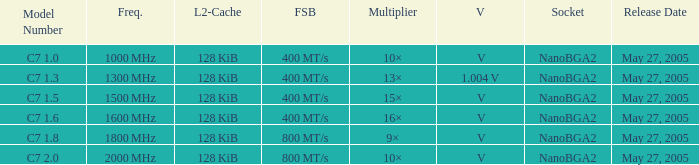What is the Frequency for Model Number c7 1.0? 1000 MHz. Parse the table in full. {'header': ['Model Number', 'Freq.', 'L2-Cache', 'FSB', 'Multiplier', 'V', 'Socket', 'Release Date'], 'rows': [['C7 1.0', '1000\u2009MHz', '128\u2009KiB', '400\u2009MT/s', '10×', '\u2009V', 'NanoBGA2', 'May 27, 2005'], ['C7 1.3', '1300\u2009MHz', '128\u2009KiB', '400\u2009MT/s', '13×', '1.004\u2009V', 'NanoBGA2', 'May 27, 2005'], ['C7 1.5', '1500\u2009MHz', '128\u2009KiB', '400\u2009MT/s', '15×', '\u2009V', 'NanoBGA2', 'May 27, 2005'], ['C7 1.6', '1600\u2009MHz', '128\u2009KiB', '400\u2009MT/s', '16×', '\u2009V', 'NanoBGA2', 'May 27, 2005'], ['C7 1.8', '1800\u2009MHz', '128\u2009KiB', '800\u2009MT/s', '9×', '\u2009V', 'NanoBGA2', 'May 27, 2005'], ['C7 2.0', '2000\u2009MHz', '128\u2009KiB', '800\u2009MT/s', '10×', '\u2009V', 'NanoBGA2', 'May 27, 2005']]} 